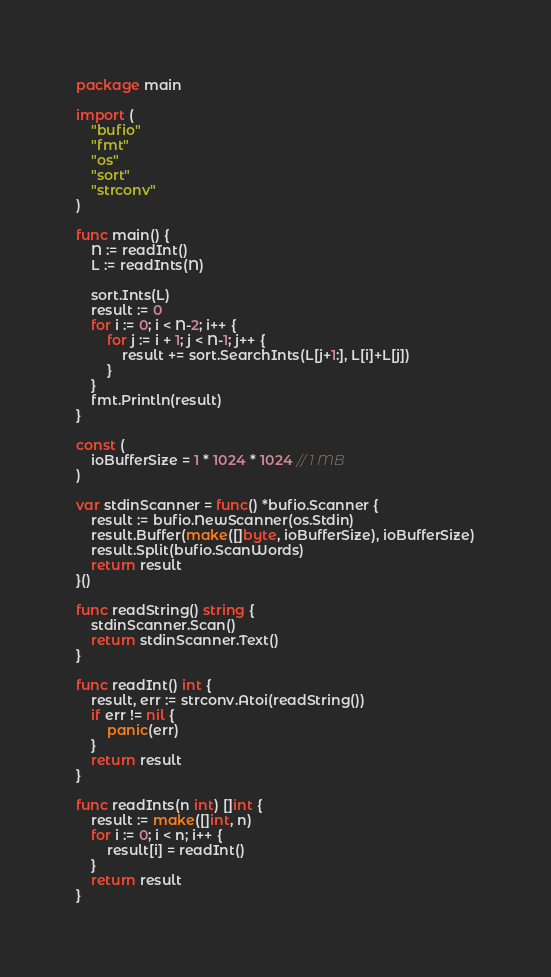Convert code to text. <code><loc_0><loc_0><loc_500><loc_500><_Go_>package main

import (
	"bufio"
	"fmt"
	"os"
	"sort"
	"strconv"
)

func main() {
	N := readInt()
	L := readInts(N)

	sort.Ints(L)
	result := 0
	for i := 0; i < N-2; i++ {
		for j := i + 1; j < N-1; j++ {
			result += sort.SearchInts(L[j+1:], L[i]+L[j])
		}
	}
	fmt.Println(result)
}

const (
	ioBufferSize = 1 * 1024 * 1024 // 1 MB
)

var stdinScanner = func() *bufio.Scanner {
	result := bufio.NewScanner(os.Stdin)
	result.Buffer(make([]byte, ioBufferSize), ioBufferSize)
	result.Split(bufio.ScanWords)
	return result
}()

func readString() string {
	stdinScanner.Scan()
	return stdinScanner.Text()
}

func readInt() int {
	result, err := strconv.Atoi(readString())
	if err != nil {
		panic(err)
	}
	return result
}

func readInts(n int) []int {
	result := make([]int, n)
	for i := 0; i < n; i++ {
		result[i] = readInt()
	}
	return result
}
</code> 